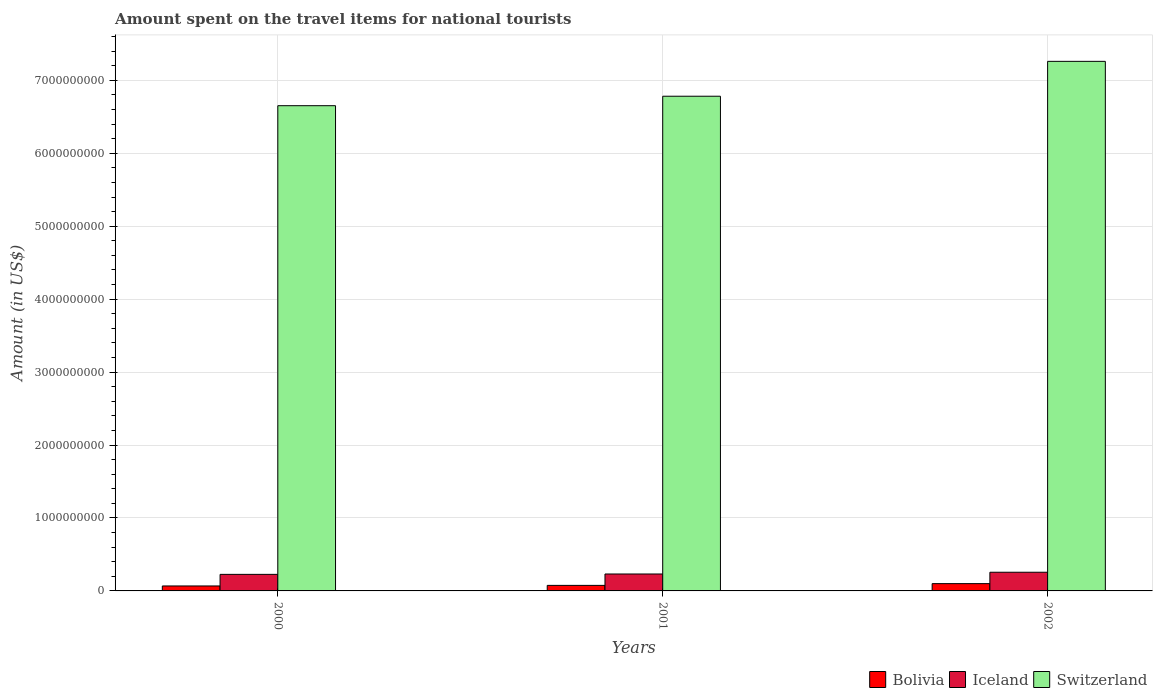How many groups of bars are there?
Offer a terse response. 3. Are the number of bars per tick equal to the number of legend labels?
Provide a succinct answer. Yes. Are the number of bars on each tick of the X-axis equal?
Your answer should be compact. Yes. How many bars are there on the 1st tick from the right?
Your response must be concise. 3. What is the amount spent on the travel items for national tourists in Iceland in 2000?
Make the answer very short. 2.27e+08. Across all years, what is the maximum amount spent on the travel items for national tourists in Switzerland?
Keep it short and to the point. 7.26e+09. Across all years, what is the minimum amount spent on the travel items for national tourists in Switzerland?
Offer a very short reply. 6.65e+09. In which year was the amount spent on the travel items for national tourists in Iceland maximum?
Your response must be concise. 2002. In which year was the amount spent on the travel items for national tourists in Bolivia minimum?
Your answer should be compact. 2000. What is the total amount spent on the travel items for national tourists in Iceland in the graph?
Your answer should be compact. 7.15e+08. What is the difference between the amount spent on the travel items for national tourists in Iceland in 2000 and that in 2001?
Keep it short and to the point. -5.00e+06. What is the difference between the amount spent on the travel items for national tourists in Iceland in 2000 and the amount spent on the travel items for national tourists in Bolivia in 2001?
Provide a short and direct response. 1.51e+08. What is the average amount spent on the travel items for national tourists in Iceland per year?
Provide a succinct answer. 2.38e+08. In the year 2002, what is the difference between the amount spent on the travel items for national tourists in Bolivia and amount spent on the travel items for national tourists in Iceland?
Your answer should be compact. -1.56e+08. In how many years, is the amount spent on the travel items for national tourists in Bolivia greater than 5400000000 US$?
Your answer should be very brief. 0. What is the ratio of the amount spent on the travel items for national tourists in Switzerland in 2000 to that in 2002?
Keep it short and to the point. 0.92. Is the amount spent on the travel items for national tourists in Bolivia in 2000 less than that in 2002?
Offer a very short reply. Yes. Is the difference between the amount spent on the travel items for national tourists in Bolivia in 2000 and 2002 greater than the difference between the amount spent on the travel items for national tourists in Iceland in 2000 and 2002?
Keep it short and to the point. No. What is the difference between the highest and the second highest amount spent on the travel items for national tourists in Bolivia?
Make the answer very short. 2.40e+07. What is the difference between the highest and the lowest amount spent on the travel items for national tourists in Bolivia?
Provide a succinct answer. 3.20e+07. In how many years, is the amount spent on the travel items for national tourists in Iceland greater than the average amount spent on the travel items for national tourists in Iceland taken over all years?
Keep it short and to the point. 1. Is the sum of the amount spent on the travel items for national tourists in Bolivia in 2001 and 2002 greater than the maximum amount spent on the travel items for national tourists in Switzerland across all years?
Your response must be concise. No. What does the 3rd bar from the left in 2000 represents?
Your answer should be compact. Switzerland. How many bars are there?
Make the answer very short. 9. How many years are there in the graph?
Your answer should be compact. 3. What is the difference between two consecutive major ticks on the Y-axis?
Give a very brief answer. 1.00e+09. Does the graph contain any zero values?
Give a very brief answer. No. Where does the legend appear in the graph?
Your response must be concise. Bottom right. How are the legend labels stacked?
Offer a terse response. Horizontal. What is the title of the graph?
Provide a succinct answer. Amount spent on the travel items for national tourists. What is the label or title of the Y-axis?
Your answer should be very brief. Amount (in US$). What is the Amount (in US$) in Bolivia in 2000?
Ensure brevity in your answer.  6.80e+07. What is the Amount (in US$) in Iceland in 2000?
Make the answer very short. 2.27e+08. What is the Amount (in US$) of Switzerland in 2000?
Your answer should be very brief. 6.65e+09. What is the Amount (in US$) in Bolivia in 2001?
Your response must be concise. 7.60e+07. What is the Amount (in US$) of Iceland in 2001?
Provide a succinct answer. 2.32e+08. What is the Amount (in US$) of Switzerland in 2001?
Provide a succinct answer. 6.78e+09. What is the Amount (in US$) of Bolivia in 2002?
Give a very brief answer. 1.00e+08. What is the Amount (in US$) in Iceland in 2002?
Offer a very short reply. 2.56e+08. What is the Amount (in US$) in Switzerland in 2002?
Make the answer very short. 7.26e+09. Across all years, what is the maximum Amount (in US$) of Iceland?
Your answer should be compact. 2.56e+08. Across all years, what is the maximum Amount (in US$) of Switzerland?
Offer a very short reply. 7.26e+09. Across all years, what is the minimum Amount (in US$) in Bolivia?
Your response must be concise. 6.80e+07. Across all years, what is the minimum Amount (in US$) in Iceland?
Ensure brevity in your answer.  2.27e+08. Across all years, what is the minimum Amount (in US$) in Switzerland?
Your answer should be very brief. 6.65e+09. What is the total Amount (in US$) of Bolivia in the graph?
Offer a very short reply. 2.44e+08. What is the total Amount (in US$) in Iceland in the graph?
Your response must be concise. 7.15e+08. What is the total Amount (in US$) of Switzerland in the graph?
Your response must be concise. 2.07e+1. What is the difference between the Amount (in US$) of Bolivia in 2000 and that in 2001?
Your answer should be very brief. -8.00e+06. What is the difference between the Amount (in US$) in Iceland in 2000 and that in 2001?
Provide a succinct answer. -5.00e+06. What is the difference between the Amount (in US$) in Switzerland in 2000 and that in 2001?
Your answer should be compact. -1.30e+08. What is the difference between the Amount (in US$) in Bolivia in 2000 and that in 2002?
Your response must be concise. -3.20e+07. What is the difference between the Amount (in US$) of Iceland in 2000 and that in 2002?
Your answer should be very brief. -2.90e+07. What is the difference between the Amount (in US$) in Switzerland in 2000 and that in 2002?
Offer a terse response. -6.08e+08. What is the difference between the Amount (in US$) in Bolivia in 2001 and that in 2002?
Provide a succinct answer. -2.40e+07. What is the difference between the Amount (in US$) in Iceland in 2001 and that in 2002?
Your response must be concise. -2.40e+07. What is the difference between the Amount (in US$) of Switzerland in 2001 and that in 2002?
Offer a terse response. -4.78e+08. What is the difference between the Amount (in US$) of Bolivia in 2000 and the Amount (in US$) of Iceland in 2001?
Provide a succinct answer. -1.64e+08. What is the difference between the Amount (in US$) of Bolivia in 2000 and the Amount (in US$) of Switzerland in 2001?
Your answer should be compact. -6.71e+09. What is the difference between the Amount (in US$) of Iceland in 2000 and the Amount (in US$) of Switzerland in 2001?
Your answer should be very brief. -6.56e+09. What is the difference between the Amount (in US$) in Bolivia in 2000 and the Amount (in US$) in Iceland in 2002?
Your answer should be compact. -1.88e+08. What is the difference between the Amount (in US$) of Bolivia in 2000 and the Amount (in US$) of Switzerland in 2002?
Provide a short and direct response. -7.19e+09. What is the difference between the Amount (in US$) in Iceland in 2000 and the Amount (in US$) in Switzerland in 2002?
Provide a short and direct response. -7.03e+09. What is the difference between the Amount (in US$) of Bolivia in 2001 and the Amount (in US$) of Iceland in 2002?
Keep it short and to the point. -1.80e+08. What is the difference between the Amount (in US$) in Bolivia in 2001 and the Amount (in US$) in Switzerland in 2002?
Your answer should be compact. -7.18e+09. What is the difference between the Amount (in US$) in Iceland in 2001 and the Amount (in US$) in Switzerland in 2002?
Your response must be concise. -7.03e+09. What is the average Amount (in US$) in Bolivia per year?
Your answer should be compact. 8.13e+07. What is the average Amount (in US$) in Iceland per year?
Make the answer very short. 2.38e+08. What is the average Amount (in US$) in Switzerland per year?
Provide a succinct answer. 6.90e+09. In the year 2000, what is the difference between the Amount (in US$) in Bolivia and Amount (in US$) in Iceland?
Offer a very short reply. -1.59e+08. In the year 2000, what is the difference between the Amount (in US$) in Bolivia and Amount (in US$) in Switzerland?
Keep it short and to the point. -6.58e+09. In the year 2000, what is the difference between the Amount (in US$) of Iceland and Amount (in US$) of Switzerland?
Make the answer very short. -6.42e+09. In the year 2001, what is the difference between the Amount (in US$) of Bolivia and Amount (in US$) of Iceland?
Offer a very short reply. -1.56e+08. In the year 2001, what is the difference between the Amount (in US$) in Bolivia and Amount (in US$) in Switzerland?
Your answer should be very brief. -6.71e+09. In the year 2001, what is the difference between the Amount (in US$) in Iceland and Amount (in US$) in Switzerland?
Give a very brief answer. -6.55e+09. In the year 2002, what is the difference between the Amount (in US$) in Bolivia and Amount (in US$) in Iceland?
Provide a short and direct response. -1.56e+08. In the year 2002, what is the difference between the Amount (in US$) in Bolivia and Amount (in US$) in Switzerland?
Your answer should be compact. -7.16e+09. In the year 2002, what is the difference between the Amount (in US$) of Iceland and Amount (in US$) of Switzerland?
Your response must be concise. -7.00e+09. What is the ratio of the Amount (in US$) of Bolivia in 2000 to that in 2001?
Give a very brief answer. 0.89. What is the ratio of the Amount (in US$) of Iceland in 2000 to that in 2001?
Your answer should be very brief. 0.98. What is the ratio of the Amount (in US$) in Switzerland in 2000 to that in 2001?
Provide a succinct answer. 0.98. What is the ratio of the Amount (in US$) of Bolivia in 2000 to that in 2002?
Ensure brevity in your answer.  0.68. What is the ratio of the Amount (in US$) in Iceland in 2000 to that in 2002?
Keep it short and to the point. 0.89. What is the ratio of the Amount (in US$) of Switzerland in 2000 to that in 2002?
Your answer should be compact. 0.92. What is the ratio of the Amount (in US$) of Bolivia in 2001 to that in 2002?
Give a very brief answer. 0.76. What is the ratio of the Amount (in US$) in Iceland in 2001 to that in 2002?
Offer a terse response. 0.91. What is the ratio of the Amount (in US$) in Switzerland in 2001 to that in 2002?
Ensure brevity in your answer.  0.93. What is the difference between the highest and the second highest Amount (in US$) in Bolivia?
Your response must be concise. 2.40e+07. What is the difference between the highest and the second highest Amount (in US$) of Iceland?
Give a very brief answer. 2.40e+07. What is the difference between the highest and the second highest Amount (in US$) in Switzerland?
Provide a short and direct response. 4.78e+08. What is the difference between the highest and the lowest Amount (in US$) of Bolivia?
Make the answer very short. 3.20e+07. What is the difference between the highest and the lowest Amount (in US$) in Iceland?
Offer a terse response. 2.90e+07. What is the difference between the highest and the lowest Amount (in US$) in Switzerland?
Provide a succinct answer. 6.08e+08. 